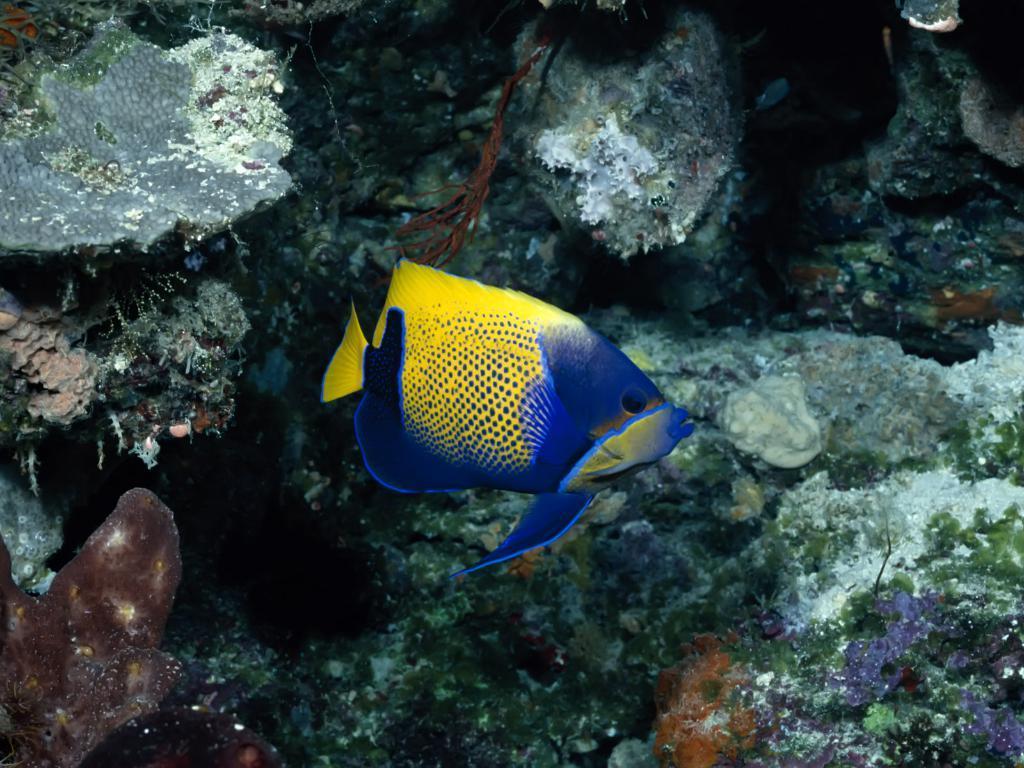Could you give a brief overview of what you see in this image? In this picture I can see a fish and corals under the water. 